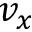<formula> <loc_0><loc_0><loc_500><loc_500>v _ { x }</formula> 